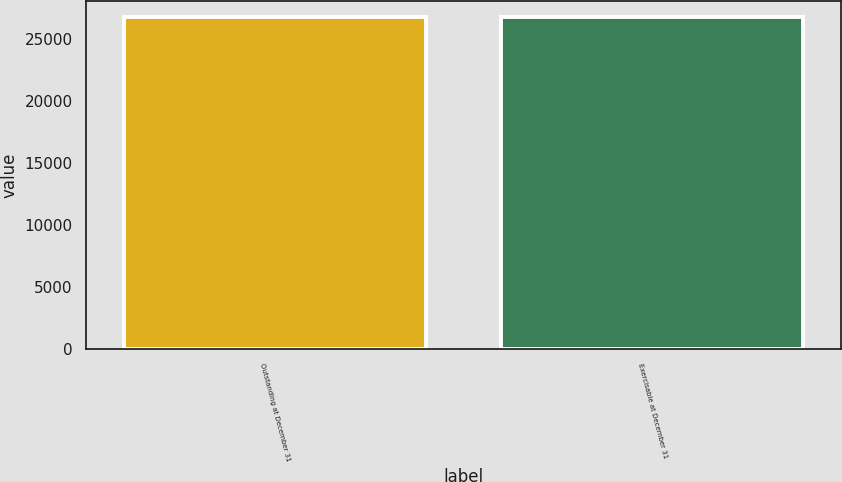Convert chart. <chart><loc_0><loc_0><loc_500><loc_500><bar_chart><fcel>Outstanding at December 31<fcel>Exercisable at December 31<nl><fcel>26726<fcel>26726.1<nl></chart> 